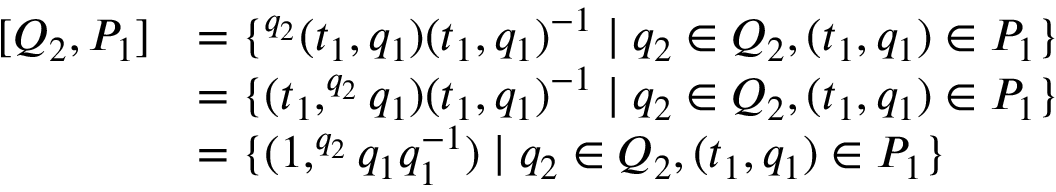<formula> <loc_0><loc_0><loc_500><loc_500>\begin{array} { r l } { [ Q _ { 2 } , P _ { 1 } ] } & { = \{ ^ { q _ { 2 } } ( t _ { 1 } , q _ { 1 } ) ( t _ { 1 } , q _ { 1 } ) ^ { - 1 } | q _ { 2 } \in Q _ { 2 } , ( t _ { 1 } , q _ { 1 } ) \in P _ { 1 } \} } \\ & { = \{ ( t _ { 1 } , ^ { q _ { 2 } } q _ { 1 } ) ( t _ { 1 } , q _ { 1 } ) ^ { - 1 } | q _ { 2 } \in Q _ { 2 } , ( t _ { 1 } , q _ { 1 } ) \in P _ { 1 } \} } \\ & { = \{ ( 1 , ^ { q _ { 2 } } q _ { 1 } q _ { 1 } ^ { - 1 } ) | q _ { 2 } \in Q _ { 2 } , ( t _ { 1 } , q _ { 1 } ) \in P _ { 1 } \} } \end{array}</formula> 